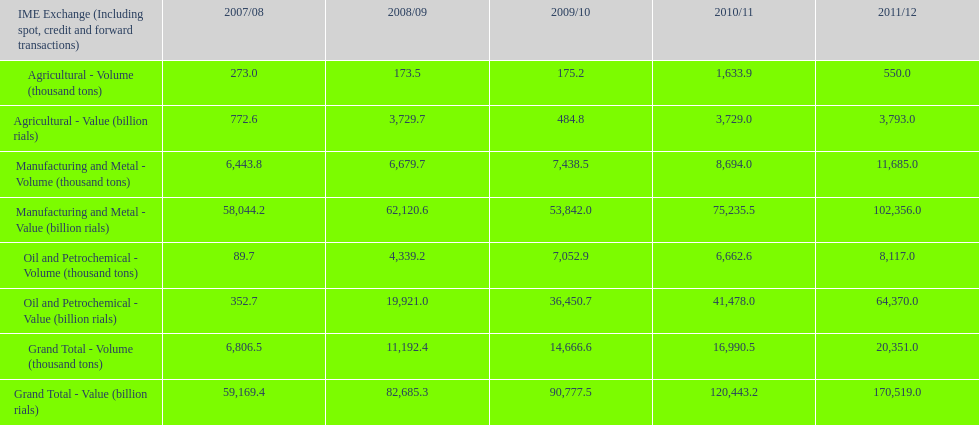Which year experienced the greatest volume in agriculture? 2010/11. 